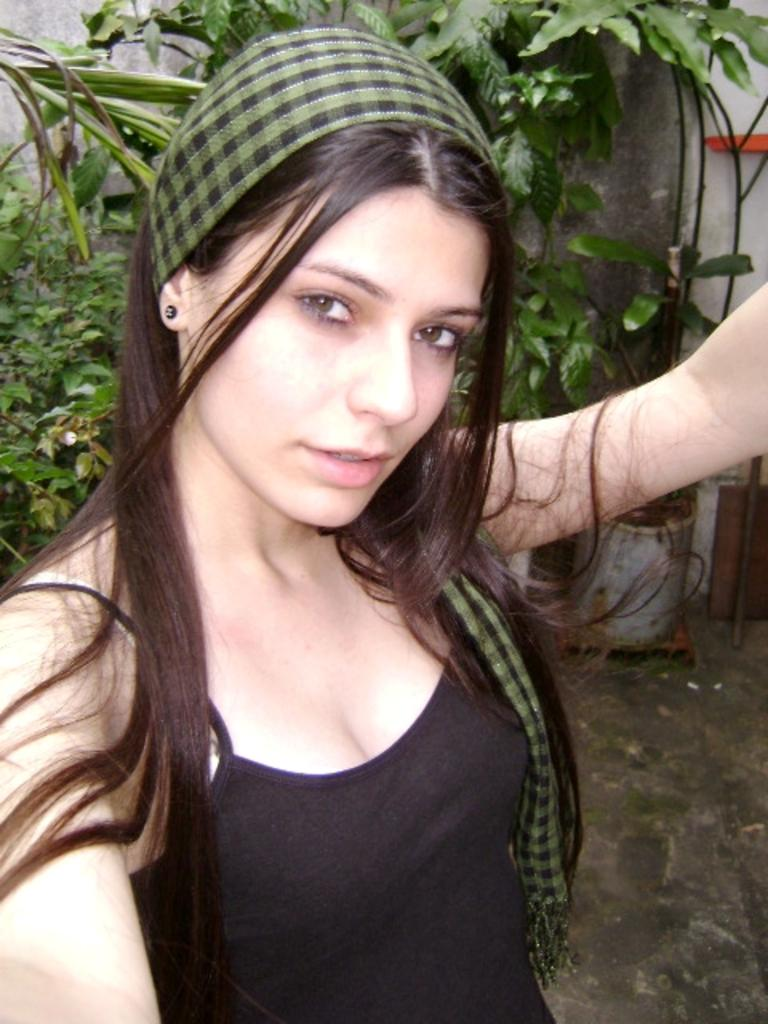Who is present in the image? There is a woman in the image. What can be seen in the background of the image? There are trees, a wall, and some objects in the background of the image. What type of orange tree can be seen near the seashore in the image? There is no orange tree or seashore present in the image. 